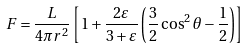<formula> <loc_0><loc_0><loc_500><loc_500>F = \frac { L } { 4 \pi r ^ { 2 } } \left [ 1 + \frac { 2 \varepsilon } { 3 + \varepsilon } \left ( \frac { 3 } { 2 } \cos ^ { 2 } \theta - \frac { 1 } { 2 } \right ) \right ]</formula> 